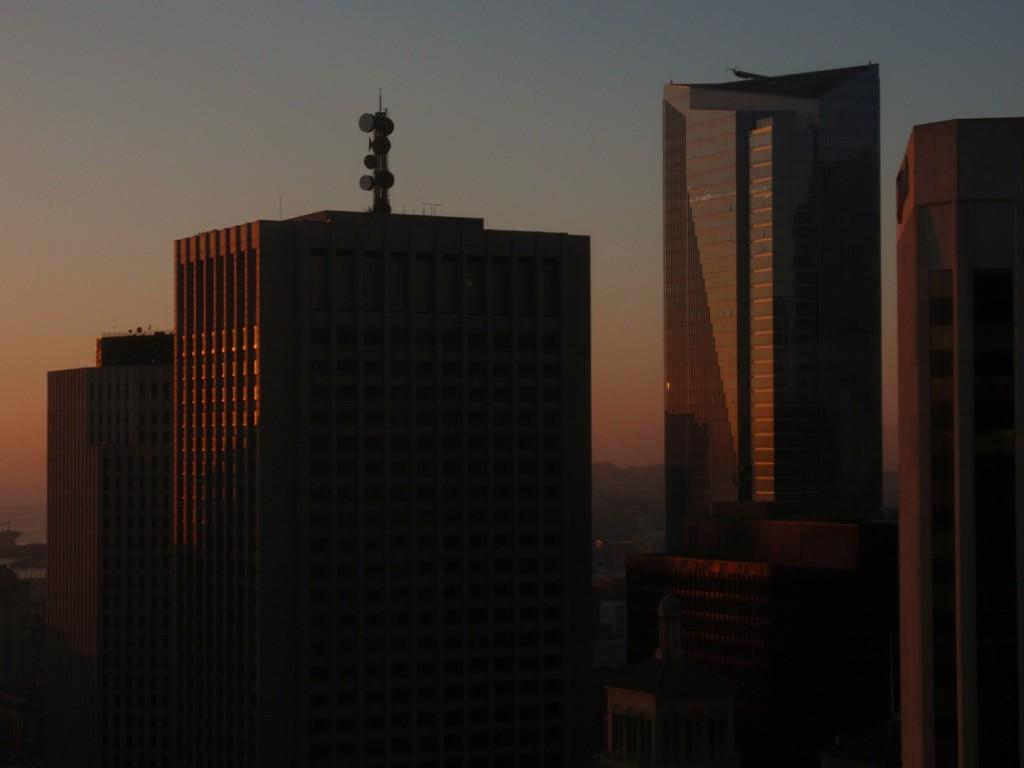What type of structures are present in the image? There are buildings in the image. Can you describe any specific features of these buildings? There is an object at the top of one of the buildings. What can be seen in the background of the image? The sky is visible in the background of the image. Can you describe the machine that the turkey is operating in the image? There is no turkey or machine present in the image. The image features buildings with an object at the top, and the sky is visible in the background. 